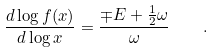Convert formula to latex. <formula><loc_0><loc_0><loc_500><loc_500>\frac { d \log f ( x ) } { d \log x } = \frac { \mp E + \frac { 1 } { 2 } \omega } { \omega } \quad .</formula> 